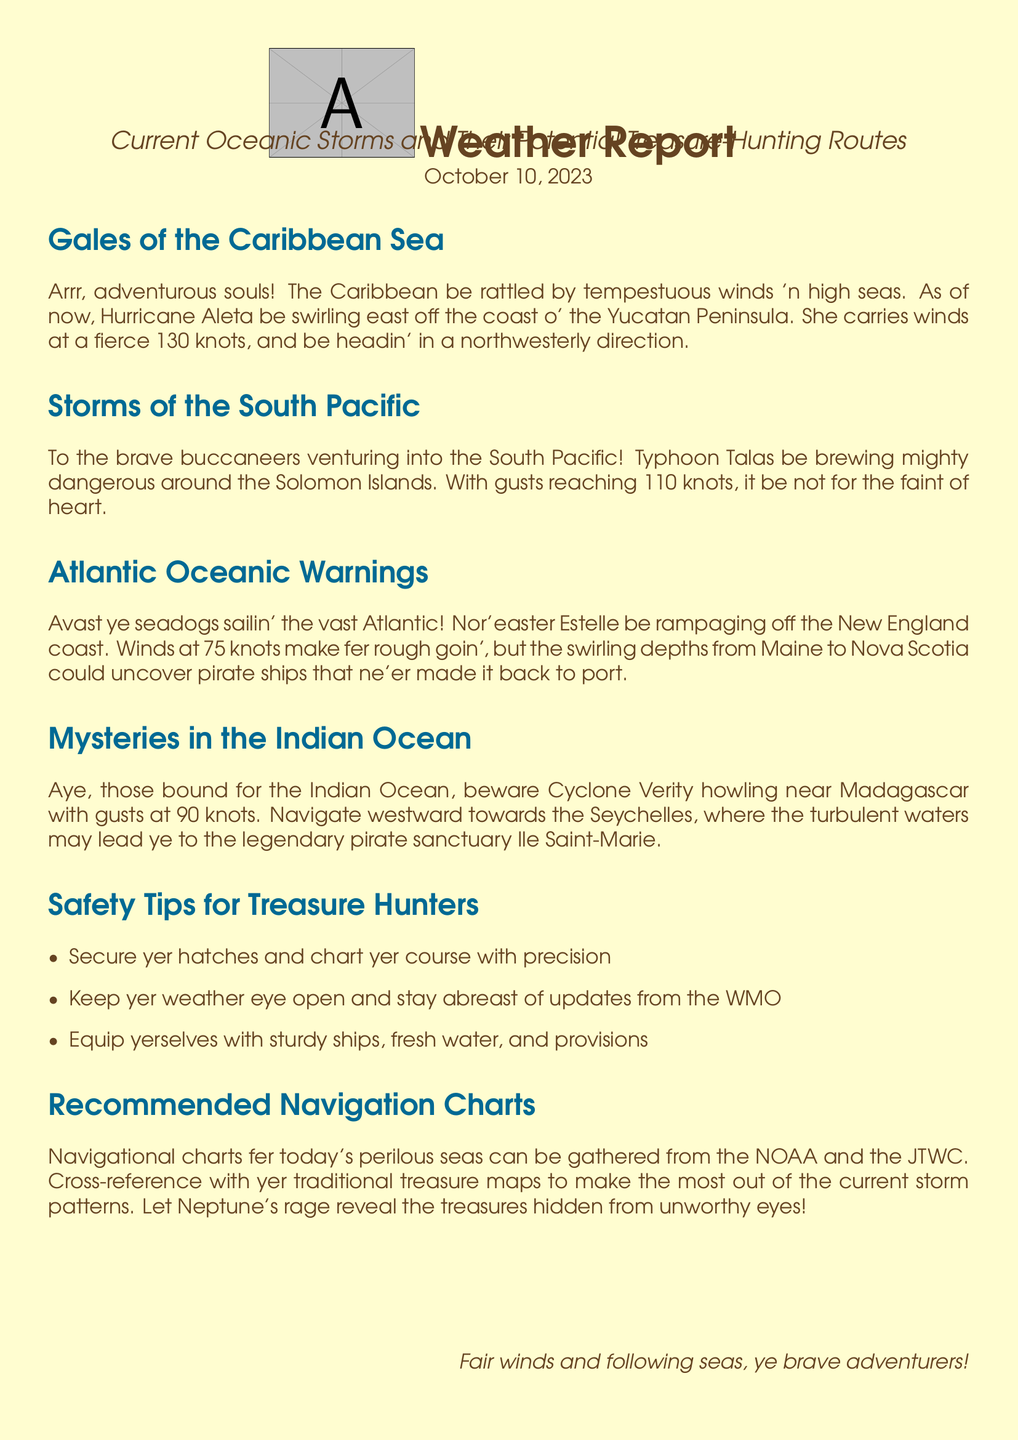What is the wind speed of Hurricane Aleta? The wind speed of Hurricane Aleta is specifically mentioned in the document as 130 knots.
Answer: 130 knots What location is affected by Typhoon Talas? The document states that Typhoon Talas is brewing around the Solomon Islands.
Answer: Solomon Islands What type of storm is causing changes in the Caribbean Sea? The document specifies that Hurricane Aleta is the storm affecting the Caribbean Sea.
Answer: Hurricane Aleta What wave conditions are reported for the Atlantic Ocean? The report mentions that Nor'easter Estelle is creating rough conditions with winds at 75 knots.
Answer: 75 knots What is the gust speed of Cyclone Verity? Cyclone Verity's gust speed is noted to be 90 knots in the document.
Answer: 90 knots Which location is recommended for navigation towards treasures in the Indian Ocean? The document suggests navigating towards the Seychelles for treasure hunting in the Indian Ocean.
Answer: Seychelles Which organization provides navigational charts? The NOAA is mentioned as a source for navigational charts in the document.
Answer: NOAA What is the main purpose of the weather report? The document's purpose is to inform of current oceanic storms and potential treasure-hunting routes for adventurers.
Answer: inform of current oceanic storms and potential treasure-hunting routes What safety measure is advised for treasure hunters? The report advises treasure hunters to secure their hatches and chart their course with precision.
Answer: secure yer hatches and chart yer course with precision 